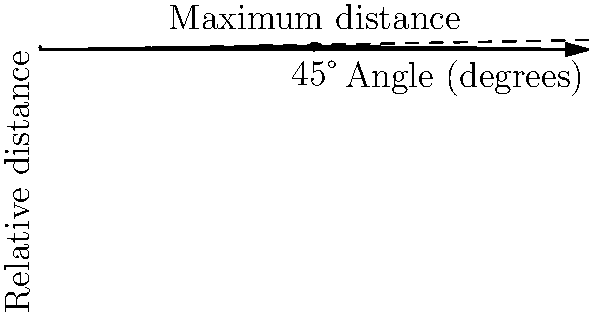As a shot put athlete, you understand the importance of the angle of release in achieving maximum distance. Based on the graph shown, which depicts the relationship between the angle of release and the relative distance achieved, what is the optimal angle of release for a shot put to achieve maximum distance? To determine the optimal angle of release for a shot put to achieve maximum distance, we need to analyze the graph:

1. The x-axis represents the angle of release in degrees.
2. The y-axis represents the relative distance achieved.
3. The solid curve shows the relationship between the angle and the relative distance.
4. The peak of this curve indicates the maximum distance achieved.

From the graph, we can observe:

1. The curve reaches its highest point at 45°.
2. A vertical dashed line is drawn from the x-axis at 45° to meet the curve at its peak.
3. This point is labeled "Maximum distance" on the graph.

The mathematical explanation for this is based on the projectile motion equation:

$$R = \frac{v^2}{g} \sin(2\theta)$$

Where:
- $R$ is the range (distance)
- $v$ is the initial velocity
- $g$ is the acceleration due to gravity
- $\theta$ is the angle of release

The $\sin(2\theta)$ term reaches its maximum value when $2\theta = 90°$, which occurs when $\theta = 45°$.

Therefore, the optimal angle of release for a shot put to achieve maximum distance is 45°.
Answer: 45° 